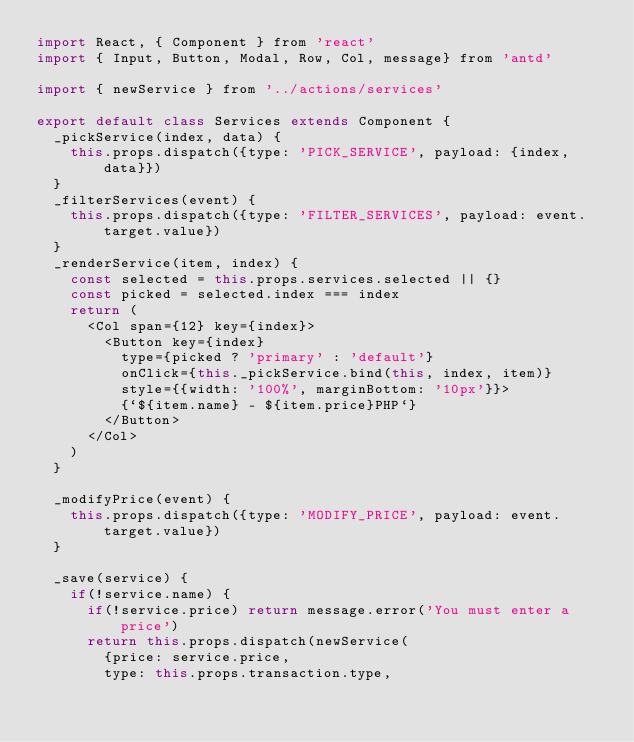Convert code to text. <code><loc_0><loc_0><loc_500><loc_500><_JavaScript_>import React, { Component } from 'react'
import { Input, Button, Modal, Row, Col, message} from 'antd'

import { newService } from '../actions/services'

export default class Services extends Component {
  _pickService(index, data) {
    this.props.dispatch({type: 'PICK_SERVICE', payload: {index, data}})
  }
  _filterServices(event) {
    this.props.dispatch({type: 'FILTER_SERVICES', payload: event.target.value})
  }
  _renderService(item, index) {
    const selected = this.props.services.selected || {}
    const picked = selected.index === index
    return (
      <Col span={12} key={index}>
        <Button key={index}
          type={picked ? 'primary' : 'default'}
          onClick={this._pickService.bind(this, index, item)}
          style={{width: '100%', marginBottom: '10px'}}>
          {`${item.name} - ${item.price}PHP`}
        </Button>
      </Col>
    )
  }

  _modifyPrice(event) {
    this.props.dispatch({type: 'MODIFY_PRICE', payload: event.target.value})
  }

  _save(service) {
    if(!service.name) {
      if(!service.price) return message.error('You must enter a price')
      return this.props.dispatch(newService(
        {price: service.price,
        type: this.props.transaction.type,</code> 